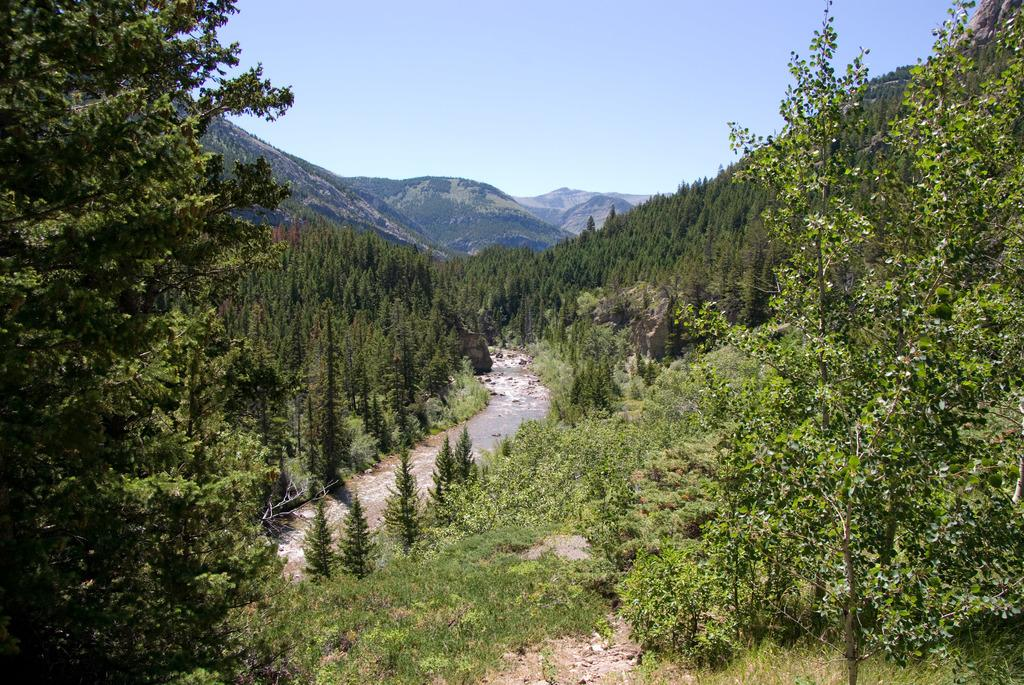What type of natural feature is present in the image? There is a river in the image. What other elements can be seen in the image? Trees are visible in the image. Can you describe the background of the image? There is a background in the image, which includes trees and the sky. What part of the natural environment is visible in the background? Trees and the sky are visible in the background of the image. What type of ink is used to write the decision on the chin in the image? There is no ink, chin, or decision present in the image. 